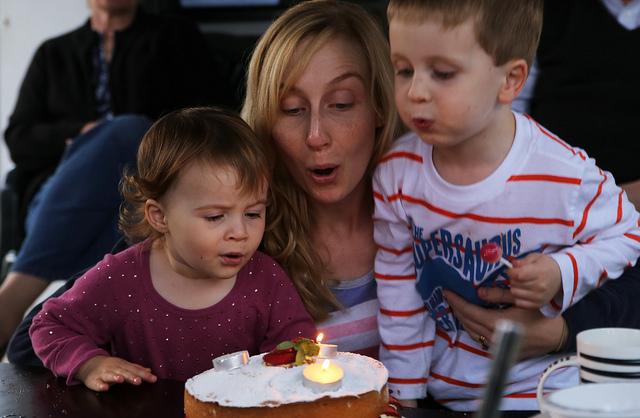What is the person helping the boy cut?
Short answer required. Cake. Where is the cake?
Write a very short answer. On table. What color is the boys shirt?
Answer briefly. White. Is he wearing green?
Keep it brief. No. What color is the candle holder?
Short answer required. Silver. Are there votives on this cake?
Write a very short answer. Yes. Are there candles tall?
Give a very brief answer. No. Are the people cutting a cake?
Be succinct. No. What does the boys t-shirt say?
Be succinct. Supersaurus. Is this a group of strangers?
Give a very brief answer. No. Is there a celebration happening?
Give a very brief answer. Yes. 